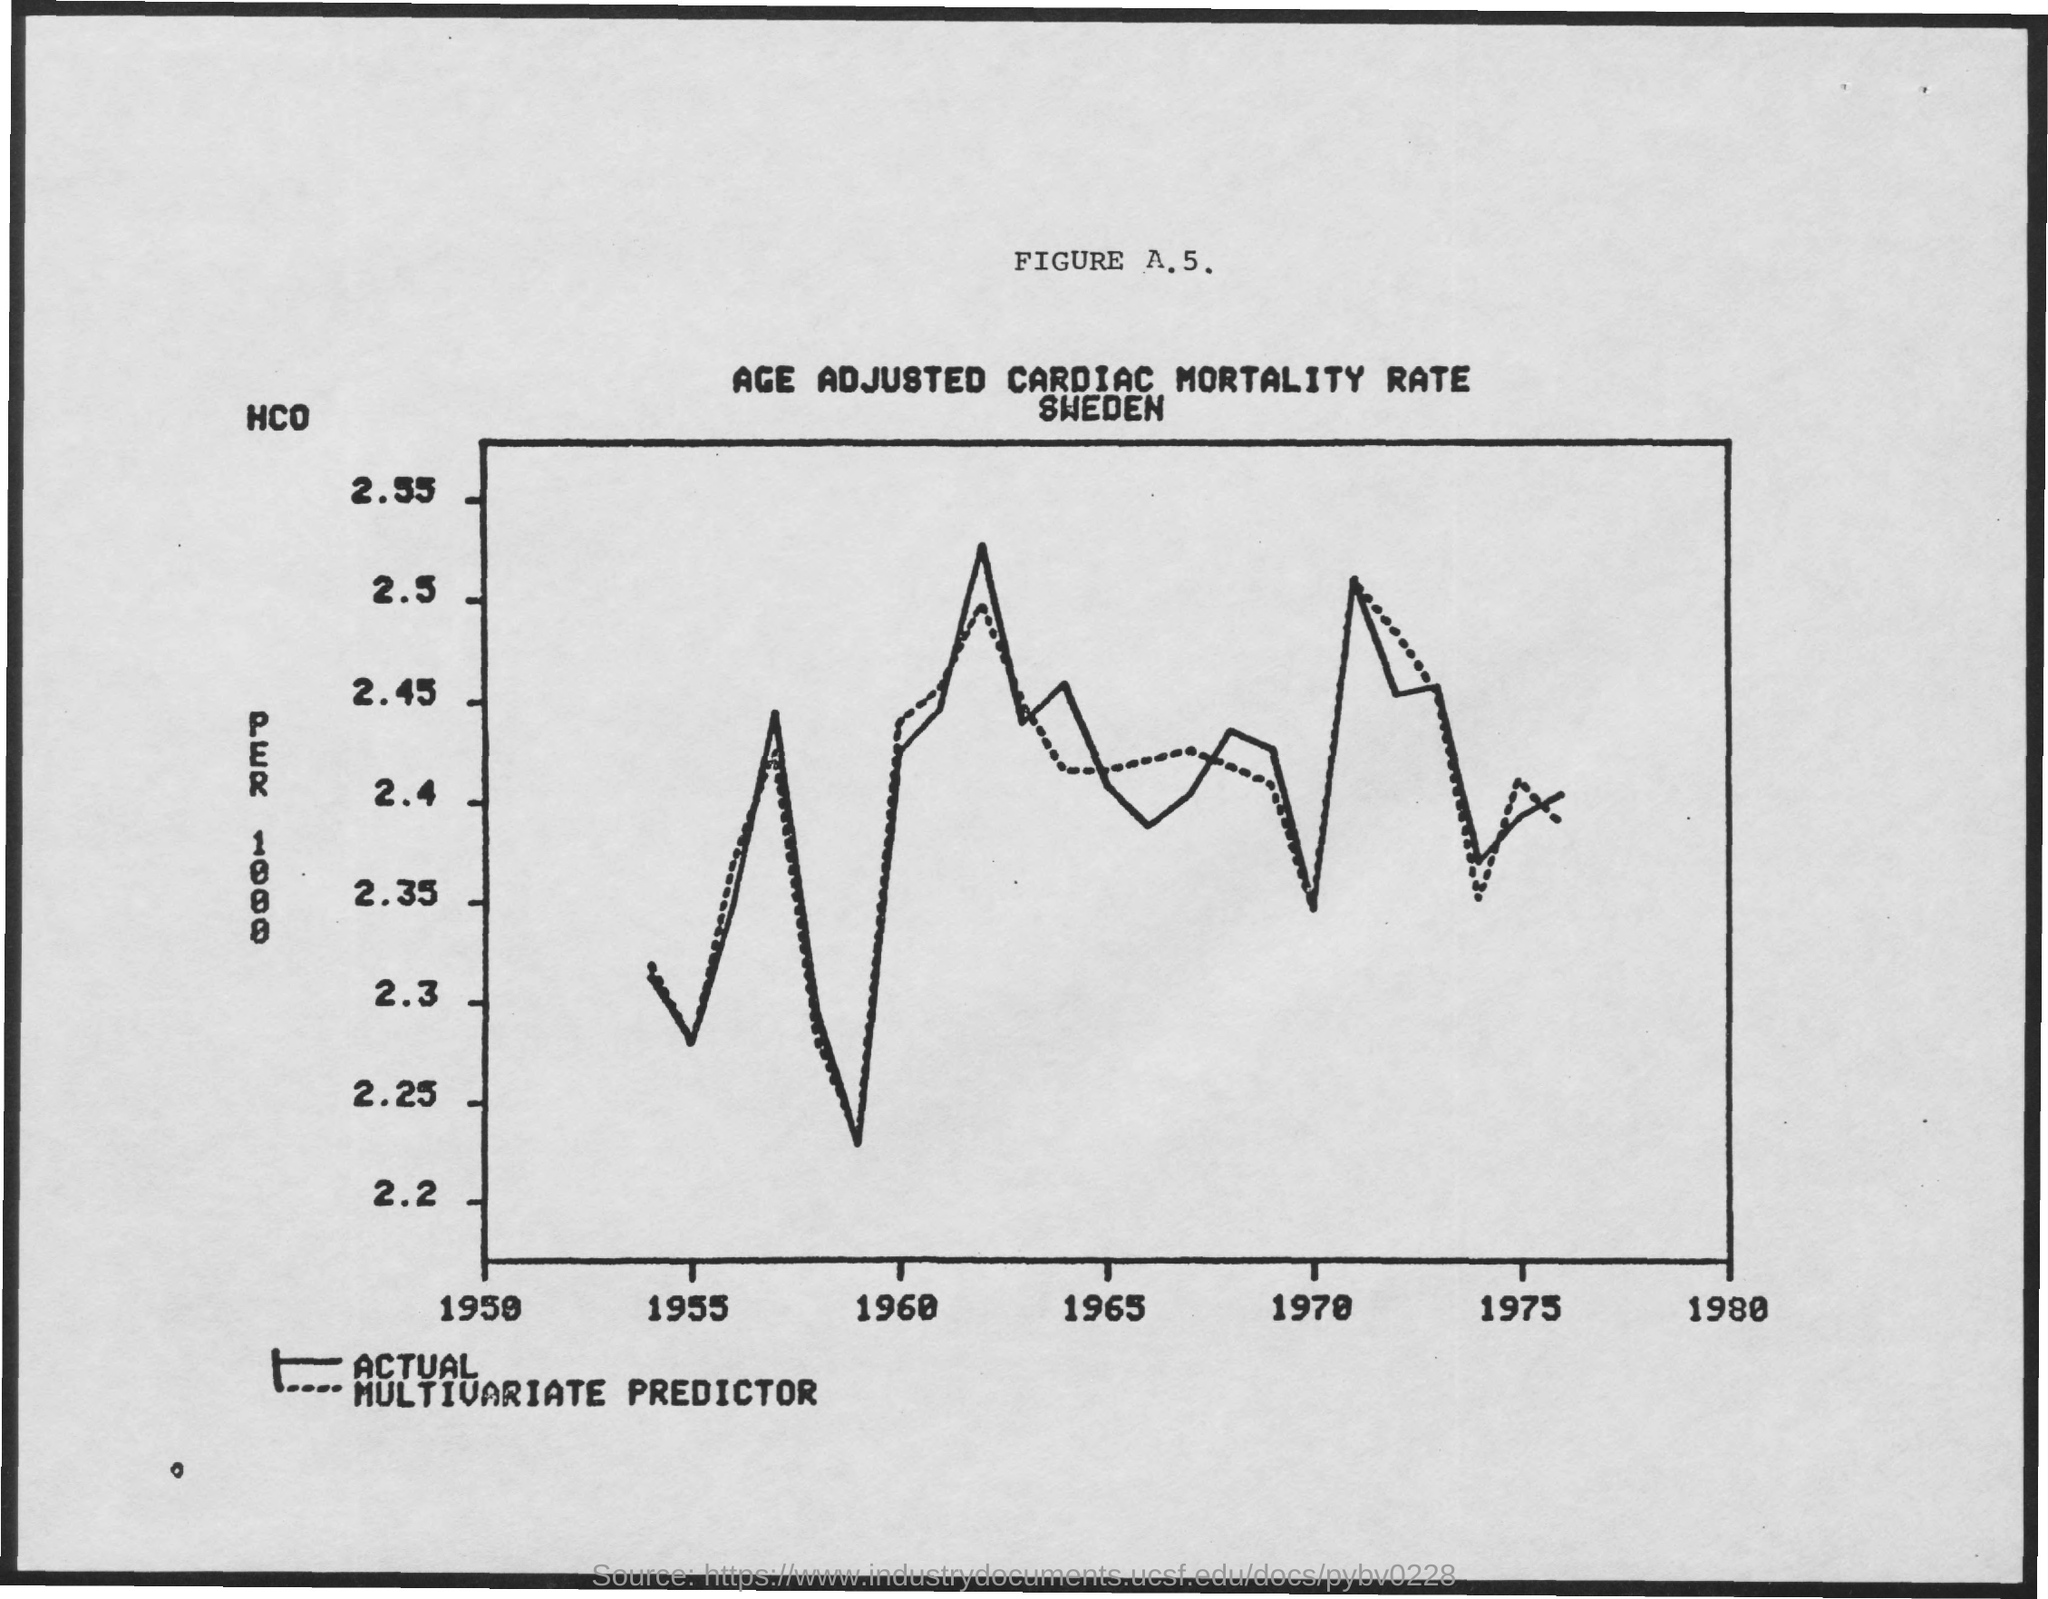Draw attention to some important aspects in this diagram. The dotted line in the graph represents a multivariate predictor, which is a type of machine learning model that predicts a target variable based on multiple input variables. 